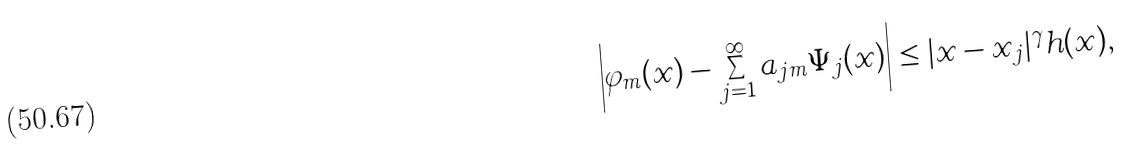Convert formula to latex. <formula><loc_0><loc_0><loc_500><loc_500>\left | \varphi _ { m } ( x ) - \sum _ { j = 1 } ^ { \infty } a _ { j m } \Psi _ { j } ( x ) \right | \leq | x - x _ { j } | ^ { \gamma } h ( x ) ,</formula> 